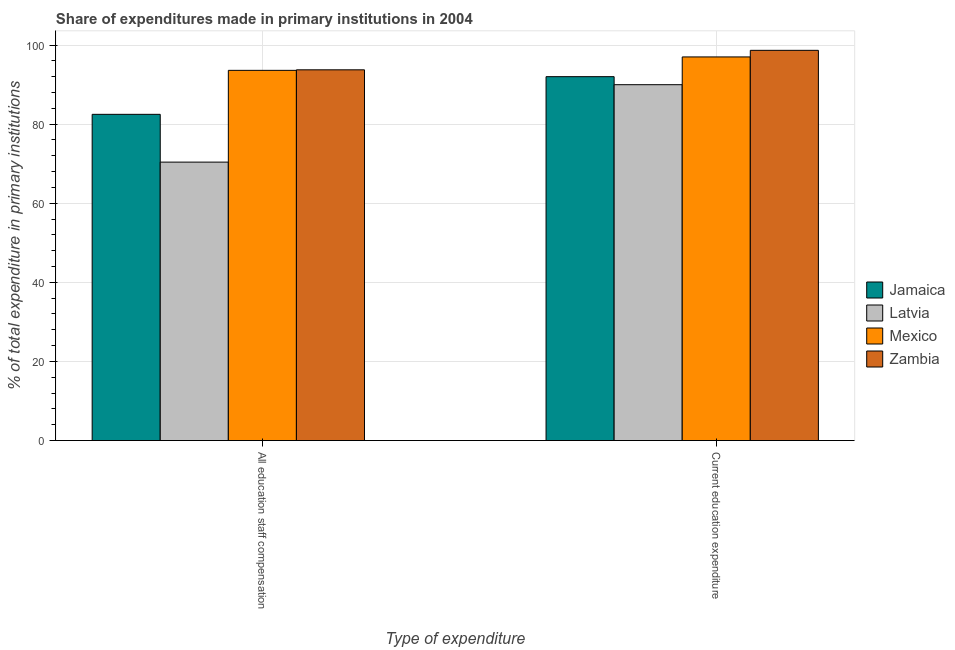How many different coloured bars are there?
Your answer should be very brief. 4. Are the number of bars per tick equal to the number of legend labels?
Keep it short and to the point. Yes. Are the number of bars on each tick of the X-axis equal?
Keep it short and to the point. Yes. How many bars are there on the 2nd tick from the right?
Your answer should be compact. 4. What is the label of the 1st group of bars from the left?
Make the answer very short. All education staff compensation. What is the expenditure in education in Latvia?
Make the answer very short. 89.97. Across all countries, what is the maximum expenditure in staff compensation?
Your answer should be compact. 93.73. Across all countries, what is the minimum expenditure in staff compensation?
Your answer should be very brief. 70.39. In which country was the expenditure in staff compensation maximum?
Make the answer very short. Zambia. In which country was the expenditure in education minimum?
Give a very brief answer. Latvia. What is the total expenditure in education in the graph?
Make the answer very short. 377.61. What is the difference between the expenditure in staff compensation in Latvia and that in Jamaica?
Offer a very short reply. -12.08. What is the difference between the expenditure in staff compensation in Jamaica and the expenditure in education in Mexico?
Provide a short and direct response. -14.51. What is the average expenditure in education per country?
Keep it short and to the point. 94.4. What is the difference between the expenditure in education and expenditure in staff compensation in Mexico?
Keep it short and to the point. 3.39. What is the ratio of the expenditure in staff compensation in Latvia to that in Zambia?
Your response must be concise. 0.75. Is the expenditure in education in Zambia less than that in Jamaica?
Provide a short and direct response. No. What does the 2nd bar from the left in All education staff compensation represents?
Provide a succinct answer. Latvia. What does the 3rd bar from the right in Current education expenditure represents?
Ensure brevity in your answer.  Latvia. How many bars are there?
Give a very brief answer. 8. Are all the bars in the graph horizontal?
Provide a short and direct response. No. How many countries are there in the graph?
Your answer should be very brief. 4. Are the values on the major ticks of Y-axis written in scientific E-notation?
Your response must be concise. No. How are the legend labels stacked?
Offer a terse response. Vertical. What is the title of the graph?
Provide a succinct answer. Share of expenditures made in primary institutions in 2004. Does "Turkmenistan" appear as one of the legend labels in the graph?
Your response must be concise. No. What is the label or title of the X-axis?
Your answer should be very brief. Type of expenditure. What is the label or title of the Y-axis?
Keep it short and to the point. % of total expenditure in primary institutions. What is the % of total expenditure in primary institutions in Jamaica in All education staff compensation?
Make the answer very short. 82.47. What is the % of total expenditure in primary institutions of Latvia in All education staff compensation?
Keep it short and to the point. 70.39. What is the % of total expenditure in primary institutions of Mexico in All education staff compensation?
Offer a terse response. 93.6. What is the % of total expenditure in primary institutions of Zambia in All education staff compensation?
Provide a succinct answer. 93.73. What is the % of total expenditure in primary institutions of Jamaica in Current education expenditure?
Provide a succinct answer. 92. What is the % of total expenditure in primary institutions in Latvia in Current education expenditure?
Give a very brief answer. 89.97. What is the % of total expenditure in primary institutions of Mexico in Current education expenditure?
Your response must be concise. 96.99. What is the % of total expenditure in primary institutions in Zambia in Current education expenditure?
Offer a very short reply. 98.65. Across all Type of expenditure, what is the maximum % of total expenditure in primary institutions of Jamaica?
Ensure brevity in your answer.  92. Across all Type of expenditure, what is the maximum % of total expenditure in primary institutions in Latvia?
Your response must be concise. 89.97. Across all Type of expenditure, what is the maximum % of total expenditure in primary institutions in Mexico?
Provide a short and direct response. 96.99. Across all Type of expenditure, what is the maximum % of total expenditure in primary institutions in Zambia?
Offer a very short reply. 98.65. Across all Type of expenditure, what is the minimum % of total expenditure in primary institutions of Jamaica?
Offer a terse response. 82.47. Across all Type of expenditure, what is the minimum % of total expenditure in primary institutions of Latvia?
Your answer should be compact. 70.39. Across all Type of expenditure, what is the minimum % of total expenditure in primary institutions of Mexico?
Ensure brevity in your answer.  93.6. Across all Type of expenditure, what is the minimum % of total expenditure in primary institutions in Zambia?
Your answer should be very brief. 93.73. What is the total % of total expenditure in primary institutions of Jamaica in the graph?
Provide a succinct answer. 174.47. What is the total % of total expenditure in primary institutions in Latvia in the graph?
Your response must be concise. 160.36. What is the total % of total expenditure in primary institutions in Mexico in the graph?
Provide a short and direct response. 190.58. What is the total % of total expenditure in primary institutions of Zambia in the graph?
Make the answer very short. 192.38. What is the difference between the % of total expenditure in primary institutions in Jamaica in All education staff compensation and that in Current education expenditure?
Offer a terse response. -9.53. What is the difference between the % of total expenditure in primary institutions of Latvia in All education staff compensation and that in Current education expenditure?
Give a very brief answer. -19.57. What is the difference between the % of total expenditure in primary institutions in Mexico in All education staff compensation and that in Current education expenditure?
Give a very brief answer. -3.39. What is the difference between the % of total expenditure in primary institutions of Zambia in All education staff compensation and that in Current education expenditure?
Provide a short and direct response. -4.93. What is the difference between the % of total expenditure in primary institutions of Jamaica in All education staff compensation and the % of total expenditure in primary institutions of Latvia in Current education expenditure?
Make the answer very short. -7.49. What is the difference between the % of total expenditure in primary institutions of Jamaica in All education staff compensation and the % of total expenditure in primary institutions of Mexico in Current education expenditure?
Offer a very short reply. -14.51. What is the difference between the % of total expenditure in primary institutions of Jamaica in All education staff compensation and the % of total expenditure in primary institutions of Zambia in Current education expenditure?
Give a very brief answer. -16.18. What is the difference between the % of total expenditure in primary institutions in Latvia in All education staff compensation and the % of total expenditure in primary institutions in Mexico in Current education expenditure?
Offer a very short reply. -26.59. What is the difference between the % of total expenditure in primary institutions in Latvia in All education staff compensation and the % of total expenditure in primary institutions in Zambia in Current education expenditure?
Offer a very short reply. -28.26. What is the difference between the % of total expenditure in primary institutions in Mexico in All education staff compensation and the % of total expenditure in primary institutions in Zambia in Current education expenditure?
Your answer should be compact. -5.06. What is the average % of total expenditure in primary institutions of Jamaica per Type of expenditure?
Your answer should be very brief. 87.24. What is the average % of total expenditure in primary institutions of Latvia per Type of expenditure?
Your response must be concise. 80.18. What is the average % of total expenditure in primary institutions of Mexico per Type of expenditure?
Your answer should be compact. 95.29. What is the average % of total expenditure in primary institutions of Zambia per Type of expenditure?
Ensure brevity in your answer.  96.19. What is the difference between the % of total expenditure in primary institutions of Jamaica and % of total expenditure in primary institutions of Latvia in All education staff compensation?
Your answer should be compact. 12.08. What is the difference between the % of total expenditure in primary institutions of Jamaica and % of total expenditure in primary institutions of Mexico in All education staff compensation?
Keep it short and to the point. -11.12. What is the difference between the % of total expenditure in primary institutions in Jamaica and % of total expenditure in primary institutions in Zambia in All education staff compensation?
Offer a terse response. -11.25. What is the difference between the % of total expenditure in primary institutions of Latvia and % of total expenditure in primary institutions of Mexico in All education staff compensation?
Ensure brevity in your answer.  -23.2. What is the difference between the % of total expenditure in primary institutions in Latvia and % of total expenditure in primary institutions in Zambia in All education staff compensation?
Your answer should be compact. -23.33. What is the difference between the % of total expenditure in primary institutions in Mexico and % of total expenditure in primary institutions in Zambia in All education staff compensation?
Offer a terse response. -0.13. What is the difference between the % of total expenditure in primary institutions in Jamaica and % of total expenditure in primary institutions in Latvia in Current education expenditure?
Make the answer very short. 2.03. What is the difference between the % of total expenditure in primary institutions of Jamaica and % of total expenditure in primary institutions of Mexico in Current education expenditure?
Provide a short and direct response. -4.99. What is the difference between the % of total expenditure in primary institutions in Jamaica and % of total expenditure in primary institutions in Zambia in Current education expenditure?
Offer a very short reply. -6.66. What is the difference between the % of total expenditure in primary institutions in Latvia and % of total expenditure in primary institutions in Mexico in Current education expenditure?
Provide a short and direct response. -7.02. What is the difference between the % of total expenditure in primary institutions of Latvia and % of total expenditure in primary institutions of Zambia in Current education expenditure?
Give a very brief answer. -8.69. What is the difference between the % of total expenditure in primary institutions of Mexico and % of total expenditure in primary institutions of Zambia in Current education expenditure?
Keep it short and to the point. -1.67. What is the ratio of the % of total expenditure in primary institutions in Jamaica in All education staff compensation to that in Current education expenditure?
Offer a very short reply. 0.9. What is the ratio of the % of total expenditure in primary institutions of Latvia in All education staff compensation to that in Current education expenditure?
Make the answer very short. 0.78. What is the ratio of the % of total expenditure in primary institutions of Mexico in All education staff compensation to that in Current education expenditure?
Offer a terse response. 0.96. What is the ratio of the % of total expenditure in primary institutions of Zambia in All education staff compensation to that in Current education expenditure?
Your answer should be compact. 0.95. What is the difference between the highest and the second highest % of total expenditure in primary institutions in Jamaica?
Offer a very short reply. 9.53. What is the difference between the highest and the second highest % of total expenditure in primary institutions in Latvia?
Your response must be concise. 19.57. What is the difference between the highest and the second highest % of total expenditure in primary institutions of Mexico?
Your answer should be compact. 3.39. What is the difference between the highest and the second highest % of total expenditure in primary institutions of Zambia?
Your response must be concise. 4.93. What is the difference between the highest and the lowest % of total expenditure in primary institutions of Jamaica?
Your answer should be compact. 9.53. What is the difference between the highest and the lowest % of total expenditure in primary institutions in Latvia?
Keep it short and to the point. 19.57. What is the difference between the highest and the lowest % of total expenditure in primary institutions of Mexico?
Provide a short and direct response. 3.39. What is the difference between the highest and the lowest % of total expenditure in primary institutions in Zambia?
Ensure brevity in your answer.  4.93. 